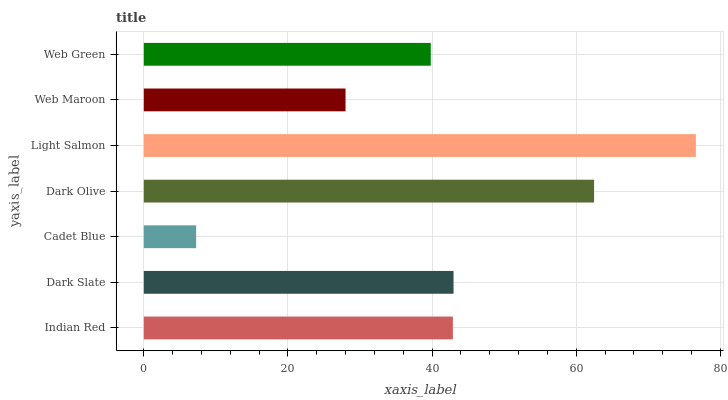Is Cadet Blue the minimum?
Answer yes or no. Yes. Is Light Salmon the maximum?
Answer yes or no. Yes. Is Dark Slate the minimum?
Answer yes or no. No. Is Dark Slate the maximum?
Answer yes or no. No. Is Dark Slate greater than Indian Red?
Answer yes or no. Yes. Is Indian Red less than Dark Slate?
Answer yes or no. Yes. Is Indian Red greater than Dark Slate?
Answer yes or no. No. Is Dark Slate less than Indian Red?
Answer yes or no. No. Is Indian Red the high median?
Answer yes or no. Yes. Is Indian Red the low median?
Answer yes or no. Yes. Is Cadet Blue the high median?
Answer yes or no. No. Is Dark Slate the low median?
Answer yes or no. No. 